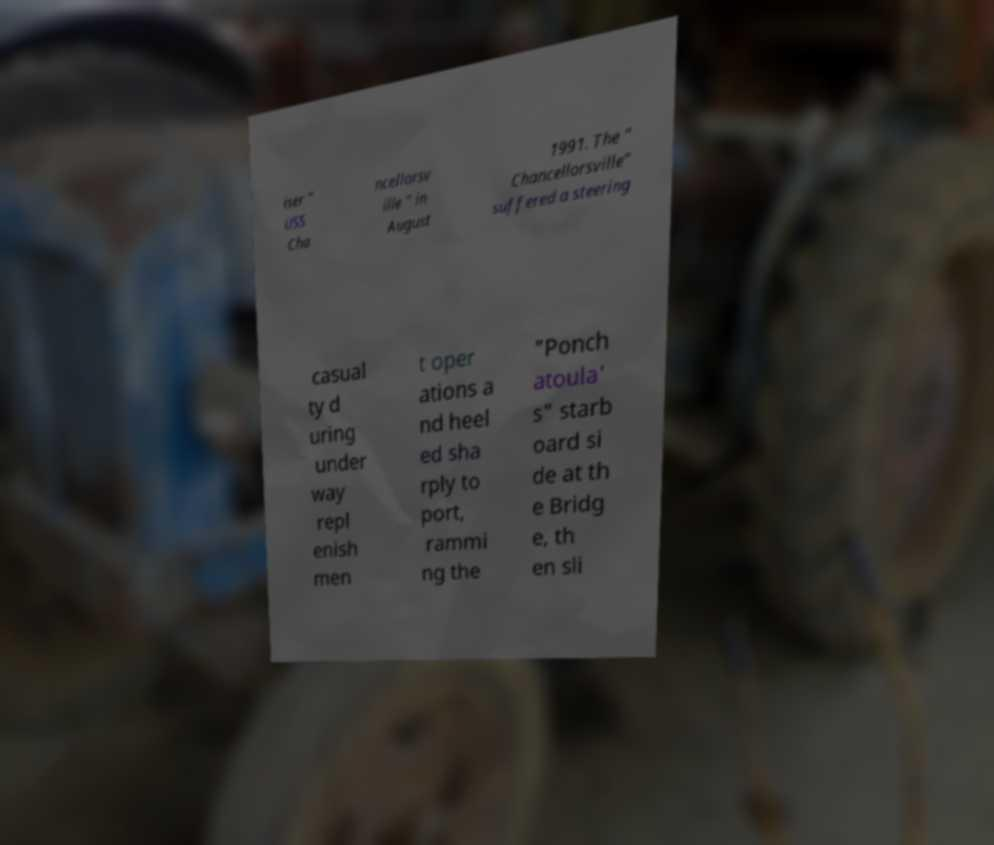Could you assist in decoding the text presented in this image and type it out clearly? iser " USS Cha ncellorsv ille " in August 1991. The " Chancellorsville" suffered a steering casual ty d uring under way repl enish men t oper ations a nd heel ed sha rply to port, rammi ng the "Ponch atoula' s" starb oard si de at th e Bridg e, th en sli 